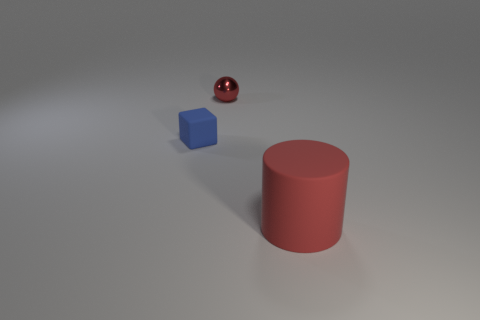Add 3 tiny red balls. How many objects exist? 6 Subtract all cylinders. How many objects are left? 2 Add 2 large rubber things. How many large rubber things exist? 3 Subtract 1 blue blocks. How many objects are left? 2 Subtract all cylinders. Subtract all red rubber things. How many objects are left? 1 Add 2 shiny balls. How many shiny balls are left? 3 